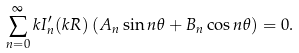Convert formula to latex. <formula><loc_0><loc_0><loc_500><loc_500>\sum _ { n = 0 } ^ { \infty } k I _ { n } ^ { \prime } ( k R ) \left ( A _ { n } \sin n \theta + B _ { n } \cos n \theta \right ) = 0 .</formula> 